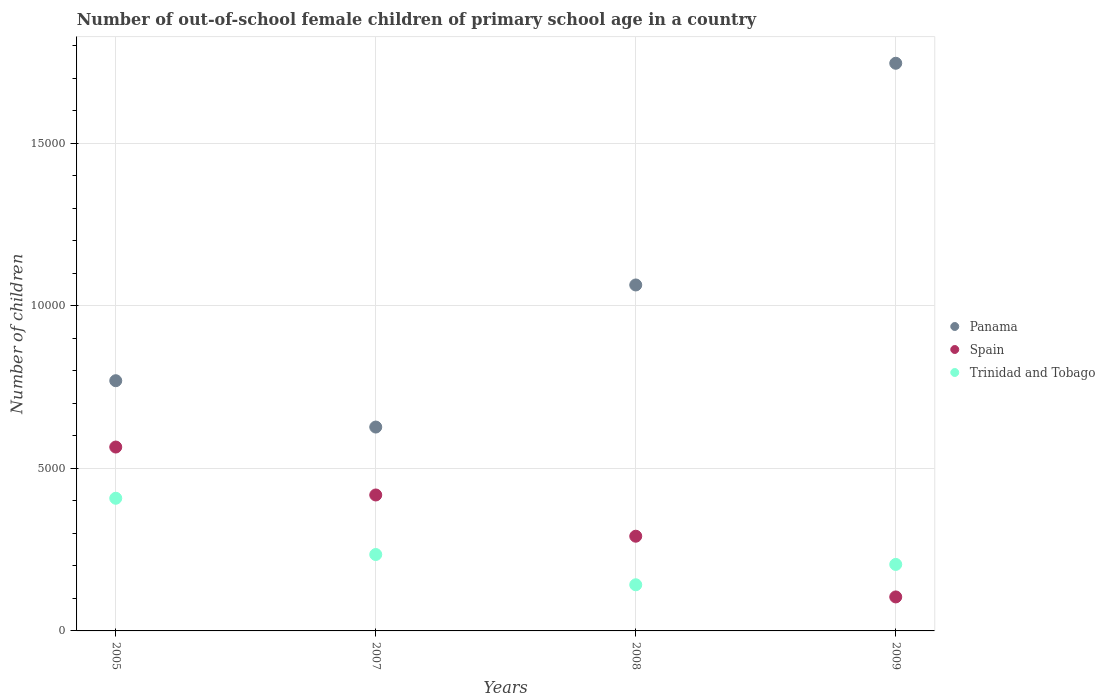Is the number of dotlines equal to the number of legend labels?
Make the answer very short. Yes. What is the number of out-of-school female children in Panama in 2007?
Your answer should be compact. 6273. Across all years, what is the maximum number of out-of-school female children in Panama?
Keep it short and to the point. 1.75e+04. Across all years, what is the minimum number of out-of-school female children in Trinidad and Tobago?
Make the answer very short. 1420. In which year was the number of out-of-school female children in Panama maximum?
Ensure brevity in your answer.  2009. What is the total number of out-of-school female children in Panama in the graph?
Provide a succinct answer. 4.21e+04. What is the difference between the number of out-of-school female children in Spain in 2007 and that in 2009?
Keep it short and to the point. 3137. What is the difference between the number of out-of-school female children in Panama in 2005 and the number of out-of-school female children in Trinidad and Tobago in 2007?
Your answer should be compact. 5348. What is the average number of out-of-school female children in Panama per year?
Provide a succinct answer. 1.05e+04. In the year 2007, what is the difference between the number of out-of-school female children in Spain and number of out-of-school female children in Trinidad and Tobago?
Offer a terse response. 1832. What is the ratio of the number of out-of-school female children in Panama in 2007 to that in 2009?
Make the answer very short. 0.36. Is the difference between the number of out-of-school female children in Spain in 2007 and 2008 greater than the difference between the number of out-of-school female children in Trinidad and Tobago in 2007 and 2008?
Ensure brevity in your answer.  Yes. What is the difference between the highest and the second highest number of out-of-school female children in Spain?
Provide a short and direct response. 1475. What is the difference between the highest and the lowest number of out-of-school female children in Panama?
Offer a very short reply. 1.12e+04. In how many years, is the number of out-of-school female children in Spain greater than the average number of out-of-school female children in Spain taken over all years?
Your answer should be compact. 2. Is the sum of the number of out-of-school female children in Trinidad and Tobago in 2005 and 2008 greater than the maximum number of out-of-school female children in Spain across all years?
Give a very brief answer. No. How many dotlines are there?
Provide a succinct answer. 3. How many years are there in the graph?
Ensure brevity in your answer.  4. Are the values on the major ticks of Y-axis written in scientific E-notation?
Keep it short and to the point. No. Where does the legend appear in the graph?
Provide a succinct answer. Center right. What is the title of the graph?
Give a very brief answer. Number of out-of-school female children of primary school age in a country. Does "Niger" appear as one of the legend labels in the graph?
Offer a very short reply. No. What is the label or title of the X-axis?
Provide a succinct answer. Years. What is the label or title of the Y-axis?
Your answer should be compact. Number of children. What is the Number of children of Panama in 2005?
Your answer should be compact. 7699. What is the Number of children in Spain in 2005?
Offer a terse response. 5658. What is the Number of children in Trinidad and Tobago in 2005?
Your response must be concise. 4082. What is the Number of children of Panama in 2007?
Give a very brief answer. 6273. What is the Number of children in Spain in 2007?
Your answer should be very brief. 4183. What is the Number of children in Trinidad and Tobago in 2007?
Offer a terse response. 2351. What is the Number of children of Panama in 2008?
Give a very brief answer. 1.06e+04. What is the Number of children of Spain in 2008?
Offer a terse response. 2914. What is the Number of children of Trinidad and Tobago in 2008?
Make the answer very short. 1420. What is the Number of children in Panama in 2009?
Your answer should be compact. 1.75e+04. What is the Number of children in Spain in 2009?
Give a very brief answer. 1046. What is the Number of children in Trinidad and Tobago in 2009?
Give a very brief answer. 2046. Across all years, what is the maximum Number of children in Panama?
Your response must be concise. 1.75e+04. Across all years, what is the maximum Number of children of Spain?
Offer a very short reply. 5658. Across all years, what is the maximum Number of children of Trinidad and Tobago?
Offer a very short reply. 4082. Across all years, what is the minimum Number of children in Panama?
Your answer should be compact. 6273. Across all years, what is the minimum Number of children of Spain?
Give a very brief answer. 1046. Across all years, what is the minimum Number of children in Trinidad and Tobago?
Offer a very short reply. 1420. What is the total Number of children in Panama in the graph?
Provide a succinct answer. 4.21e+04. What is the total Number of children in Spain in the graph?
Make the answer very short. 1.38e+04. What is the total Number of children in Trinidad and Tobago in the graph?
Keep it short and to the point. 9899. What is the difference between the Number of children in Panama in 2005 and that in 2007?
Provide a short and direct response. 1426. What is the difference between the Number of children of Spain in 2005 and that in 2007?
Your response must be concise. 1475. What is the difference between the Number of children of Trinidad and Tobago in 2005 and that in 2007?
Keep it short and to the point. 1731. What is the difference between the Number of children in Panama in 2005 and that in 2008?
Your response must be concise. -2946. What is the difference between the Number of children of Spain in 2005 and that in 2008?
Your answer should be compact. 2744. What is the difference between the Number of children of Trinidad and Tobago in 2005 and that in 2008?
Your answer should be compact. 2662. What is the difference between the Number of children in Panama in 2005 and that in 2009?
Ensure brevity in your answer.  -9768. What is the difference between the Number of children of Spain in 2005 and that in 2009?
Offer a very short reply. 4612. What is the difference between the Number of children of Trinidad and Tobago in 2005 and that in 2009?
Ensure brevity in your answer.  2036. What is the difference between the Number of children of Panama in 2007 and that in 2008?
Your answer should be very brief. -4372. What is the difference between the Number of children of Spain in 2007 and that in 2008?
Your answer should be very brief. 1269. What is the difference between the Number of children in Trinidad and Tobago in 2007 and that in 2008?
Offer a very short reply. 931. What is the difference between the Number of children of Panama in 2007 and that in 2009?
Ensure brevity in your answer.  -1.12e+04. What is the difference between the Number of children in Spain in 2007 and that in 2009?
Provide a short and direct response. 3137. What is the difference between the Number of children of Trinidad and Tobago in 2007 and that in 2009?
Your answer should be very brief. 305. What is the difference between the Number of children of Panama in 2008 and that in 2009?
Your answer should be very brief. -6822. What is the difference between the Number of children in Spain in 2008 and that in 2009?
Provide a short and direct response. 1868. What is the difference between the Number of children in Trinidad and Tobago in 2008 and that in 2009?
Keep it short and to the point. -626. What is the difference between the Number of children in Panama in 2005 and the Number of children in Spain in 2007?
Make the answer very short. 3516. What is the difference between the Number of children of Panama in 2005 and the Number of children of Trinidad and Tobago in 2007?
Ensure brevity in your answer.  5348. What is the difference between the Number of children in Spain in 2005 and the Number of children in Trinidad and Tobago in 2007?
Offer a terse response. 3307. What is the difference between the Number of children in Panama in 2005 and the Number of children in Spain in 2008?
Keep it short and to the point. 4785. What is the difference between the Number of children of Panama in 2005 and the Number of children of Trinidad and Tobago in 2008?
Your response must be concise. 6279. What is the difference between the Number of children of Spain in 2005 and the Number of children of Trinidad and Tobago in 2008?
Your answer should be very brief. 4238. What is the difference between the Number of children in Panama in 2005 and the Number of children in Spain in 2009?
Make the answer very short. 6653. What is the difference between the Number of children in Panama in 2005 and the Number of children in Trinidad and Tobago in 2009?
Give a very brief answer. 5653. What is the difference between the Number of children of Spain in 2005 and the Number of children of Trinidad and Tobago in 2009?
Provide a short and direct response. 3612. What is the difference between the Number of children in Panama in 2007 and the Number of children in Spain in 2008?
Ensure brevity in your answer.  3359. What is the difference between the Number of children in Panama in 2007 and the Number of children in Trinidad and Tobago in 2008?
Keep it short and to the point. 4853. What is the difference between the Number of children of Spain in 2007 and the Number of children of Trinidad and Tobago in 2008?
Offer a terse response. 2763. What is the difference between the Number of children in Panama in 2007 and the Number of children in Spain in 2009?
Keep it short and to the point. 5227. What is the difference between the Number of children of Panama in 2007 and the Number of children of Trinidad and Tobago in 2009?
Your response must be concise. 4227. What is the difference between the Number of children of Spain in 2007 and the Number of children of Trinidad and Tobago in 2009?
Offer a very short reply. 2137. What is the difference between the Number of children of Panama in 2008 and the Number of children of Spain in 2009?
Provide a succinct answer. 9599. What is the difference between the Number of children in Panama in 2008 and the Number of children in Trinidad and Tobago in 2009?
Keep it short and to the point. 8599. What is the difference between the Number of children of Spain in 2008 and the Number of children of Trinidad and Tobago in 2009?
Offer a very short reply. 868. What is the average Number of children of Panama per year?
Your answer should be very brief. 1.05e+04. What is the average Number of children of Spain per year?
Your response must be concise. 3450.25. What is the average Number of children in Trinidad and Tobago per year?
Offer a very short reply. 2474.75. In the year 2005, what is the difference between the Number of children in Panama and Number of children in Spain?
Keep it short and to the point. 2041. In the year 2005, what is the difference between the Number of children of Panama and Number of children of Trinidad and Tobago?
Ensure brevity in your answer.  3617. In the year 2005, what is the difference between the Number of children of Spain and Number of children of Trinidad and Tobago?
Ensure brevity in your answer.  1576. In the year 2007, what is the difference between the Number of children in Panama and Number of children in Spain?
Provide a short and direct response. 2090. In the year 2007, what is the difference between the Number of children of Panama and Number of children of Trinidad and Tobago?
Keep it short and to the point. 3922. In the year 2007, what is the difference between the Number of children of Spain and Number of children of Trinidad and Tobago?
Ensure brevity in your answer.  1832. In the year 2008, what is the difference between the Number of children of Panama and Number of children of Spain?
Make the answer very short. 7731. In the year 2008, what is the difference between the Number of children in Panama and Number of children in Trinidad and Tobago?
Offer a terse response. 9225. In the year 2008, what is the difference between the Number of children in Spain and Number of children in Trinidad and Tobago?
Your response must be concise. 1494. In the year 2009, what is the difference between the Number of children of Panama and Number of children of Spain?
Ensure brevity in your answer.  1.64e+04. In the year 2009, what is the difference between the Number of children of Panama and Number of children of Trinidad and Tobago?
Your answer should be very brief. 1.54e+04. In the year 2009, what is the difference between the Number of children in Spain and Number of children in Trinidad and Tobago?
Your response must be concise. -1000. What is the ratio of the Number of children in Panama in 2005 to that in 2007?
Provide a short and direct response. 1.23. What is the ratio of the Number of children in Spain in 2005 to that in 2007?
Provide a short and direct response. 1.35. What is the ratio of the Number of children in Trinidad and Tobago in 2005 to that in 2007?
Your answer should be very brief. 1.74. What is the ratio of the Number of children in Panama in 2005 to that in 2008?
Make the answer very short. 0.72. What is the ratio of the Number of children in Spain in 2005 to that in 2008?
Keep it short and to the point. 1.94. What is the ratio of the Number of children of Trinidad and Tobago in 2005 to that in 2008?
Make the answer very short. 2.87. What is the ratio of the Number of children of Panama in 2005 to that in 2009?
Your response must be concise. 0.44. What is the ratio of the Number of children in Spain in 2005 to that in 2009?
Offer a very short reply. 5.41. What is the ratio of the Number of children in Trinidad and Tobago in 2005 to that in 2009?
Make the answer very short. 2. What is the ratio of the Number of children of Panama in 2007 to that in 2008?
Your answer should be compact. 0.59. What is the ratio of the Number of children in Spain in 2007 to that in 2008?
Keep it short and to the point. 1.44. What is the ratio of the Number of children in Trinidad and Tobago in 2007 to that in 2008?
Make the answer very short. 1.66. What is the ratio of the Number of children of Panama in 2007 to that in 2009?
Give a very brief answer. 0.36. What is the ratio of the Number of children of Spain in 2007 to that in 2009?
Provide a short and direct response. 4. What is the ratio of the Number of children in Trinidad and Tobago in 2007 to that in 2009?
Provide a short and direct response. 1.15. What is the ratio of the Number of children in Panama in 2008 to that in 2009?
Offer a terse response. 0.61. What is the ratio of the Number of children of Spain in 2008 to that in 2009?
Your answer should be compact. 2.79. What is the ratio of the Number of children in Trinidad and Tobago in 2008 to that in 2009?
Ensure brevity in your answer.  0.69. What is the difference between the highest and the second highest Number of children in Panama?
Your response must be concise. 6822. What is the difference between the highest and the second highest Number of children of Spain?
Your answer should be very brief. 1475. What is the difference between the highest and the second highest Number of children of Trinidad and Tobago?
Provide a short and direct response. 1731. What is the difference between the highest and the lowest Number of children in Panama?
Offer a very short reply. 1.12e+04. What is the difference between the highest and the lowest Number of children of Spain?
Offer a very short reply. 4612. What is the difference between the highest and the lowest Number of children in Trinidad and Tobago?
Your answer should be compact. 2662. 